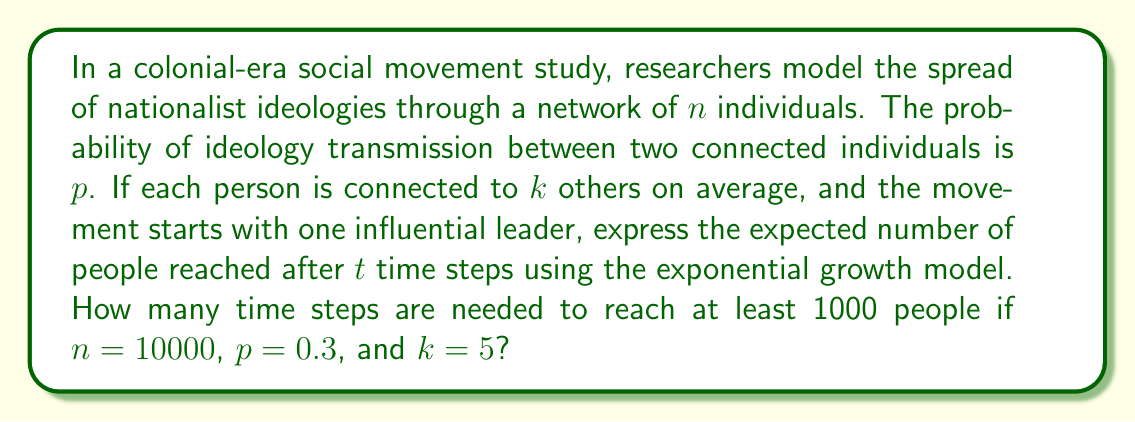Can you answer this question? 1) The exponential growth model for the spread of the movement is:

   $$N(t) = (1 + pkp)^t$$

   Where $N(t)$ is the number of people reached after $t$ time steps, and $p$ is the transmission probability.

2) We want to find $t$ when $N(t) \geq 1000$. Let's set up the inequality:

   $$(1 + pkp)^t \geq 1000$$

3) Substitute the given values: $p = 0.3$, $k = 5$

   $$(1 + 5 \cdot 0.3 \cdot 0.3)^t \geq 1000$$
   $$(1 + 0.45)^t \geq 1000$$
   $$1.45^t \geq 1000$$

4) Take the natural logarithm of both sides:

   $$t \cdot \ln(1.45) \geq \ln(1000)$$

5) Solve for $t$:

   $$t \geq \frac{\ln(1000)}{\ln(1.45)}$$
   $$t \geq \frac{6.908}{0.372}$$
   $$t \geq 18.57$$

6) Since $t$ must be a whole number of time steps, we round up to the nearest integer.
Answer: 19 time steps 